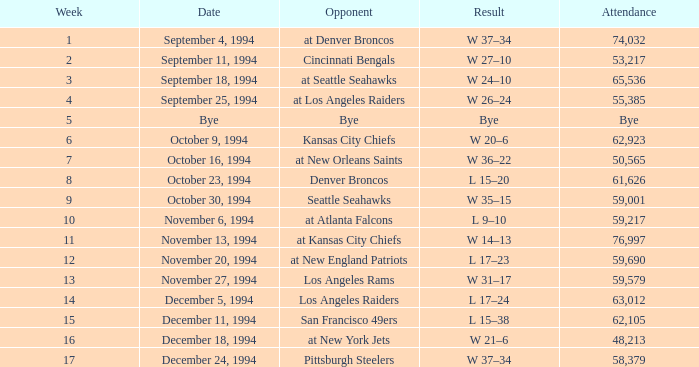Could you parse the entire table? {'header': ['Week', 'Date', 'Opponent', 'Result', 'Attendance'], 'rows': [['1', 'September 4, 1994', 'at Denver Broncos', 'W 37–34', '74,032'], ['2', 'September 11, 1994', 'Cincinnati Bengals', 'W 27–10', '53,217'], ['3', 'September 18, 1994', 'at Seattle Seahawks', 'W 24–10', '65,536'], ['4', 'September 25, 1994', 'at Los Angeles Raiders', 'W 26–24', '55,385'], ['5', 'Bye', 'Bye', 'Bye', 'Bye'], ['6', 'October 9, 1994', 'Kansas City Chiefs', 'W 20–6', '62,923'], ['7', 'October 16, 1994', 'at New Orleans Saints', 'W 36–22', '50,565'], ['8', 'October 23, 1994', 'Denver Broncos', 'L 15–20', '61,626'], ['9', 'October 30, 1994', 'Seattle Seahawks', 'W 35–15', '59,001'], ['10', 'November 6, 1994', 'at Atlanta Falcons', 'L 9–10', '59,217'], ['11', 'November 13, 1994', 'at Kansas City Chiefs', 'W 14–13', '76,997'], ['12', 'November 20, 1994', 'at New England Patriots', 'L 17–23', '59,690'], ['13', 'November 27, 1994', 'Los Angeles Rams', 'W 31–17', '59,579'], ['14', 'December 5, 1994', 'Los Angeles Raiders', 'L 17–24', '63,012'], ['15', 'December 11, 1994', 'San Francisco 49ers', 'L 15–38', '62,105'], ['16', 'December 18, 1994', 'at New York Jets', 'W 21–6', '48,213'], ['17', 'December 24, 1994', 'Pittsburgh Steelers', 'W 37–34', '58,379']]} In the game on or before week 9, who was the opponent when the attendance was 61,626? Denver Broncos. 